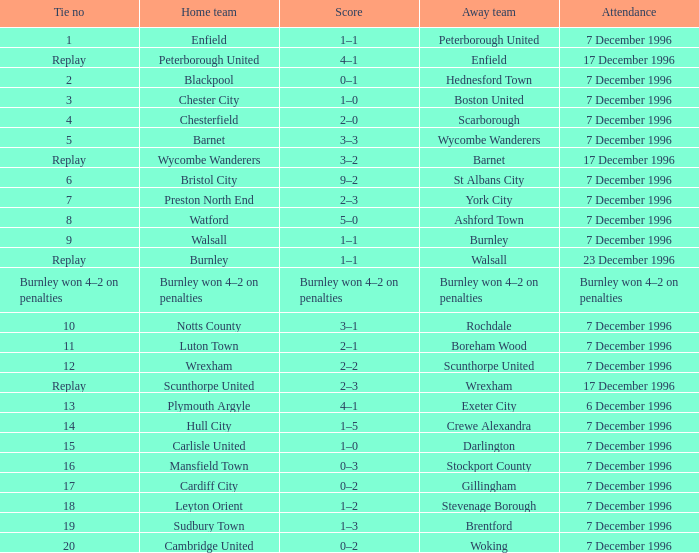What was the turnout for walsall's home team games? 7 December 1996. 